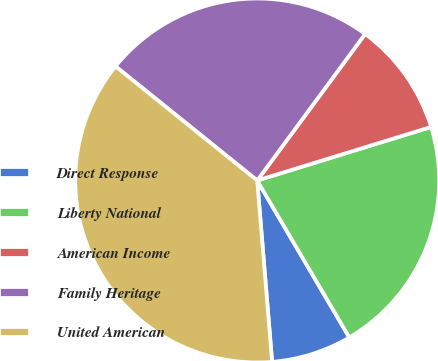<chart> <loc_0><loc_0><loc_500><loc_500><pie_chart><fcel>Direct Response<fcel>Liberty National<fcel>American Income<fcel>Family Heritage<fcel>United American<nl><fcel>7.14%<fcel>21.31%<fcel>10.14%<fcel>24.31%<fcel>37.1%<nl></chart> 